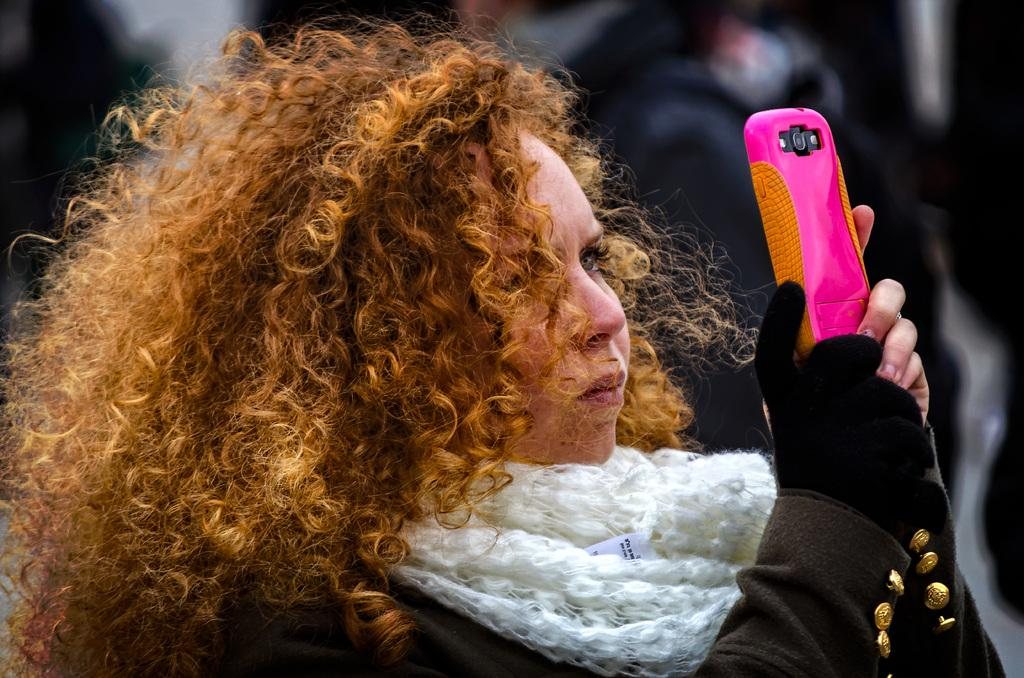What is the main subject of the image? The main subject of the image is a woman. What is the woman holding in her hands? The woman is holding a mobile in her hands. What type of news can be heard coming from the radio in the image? There is no radio present in the image, so it's not possible to determine what, if any, news might be heard. 